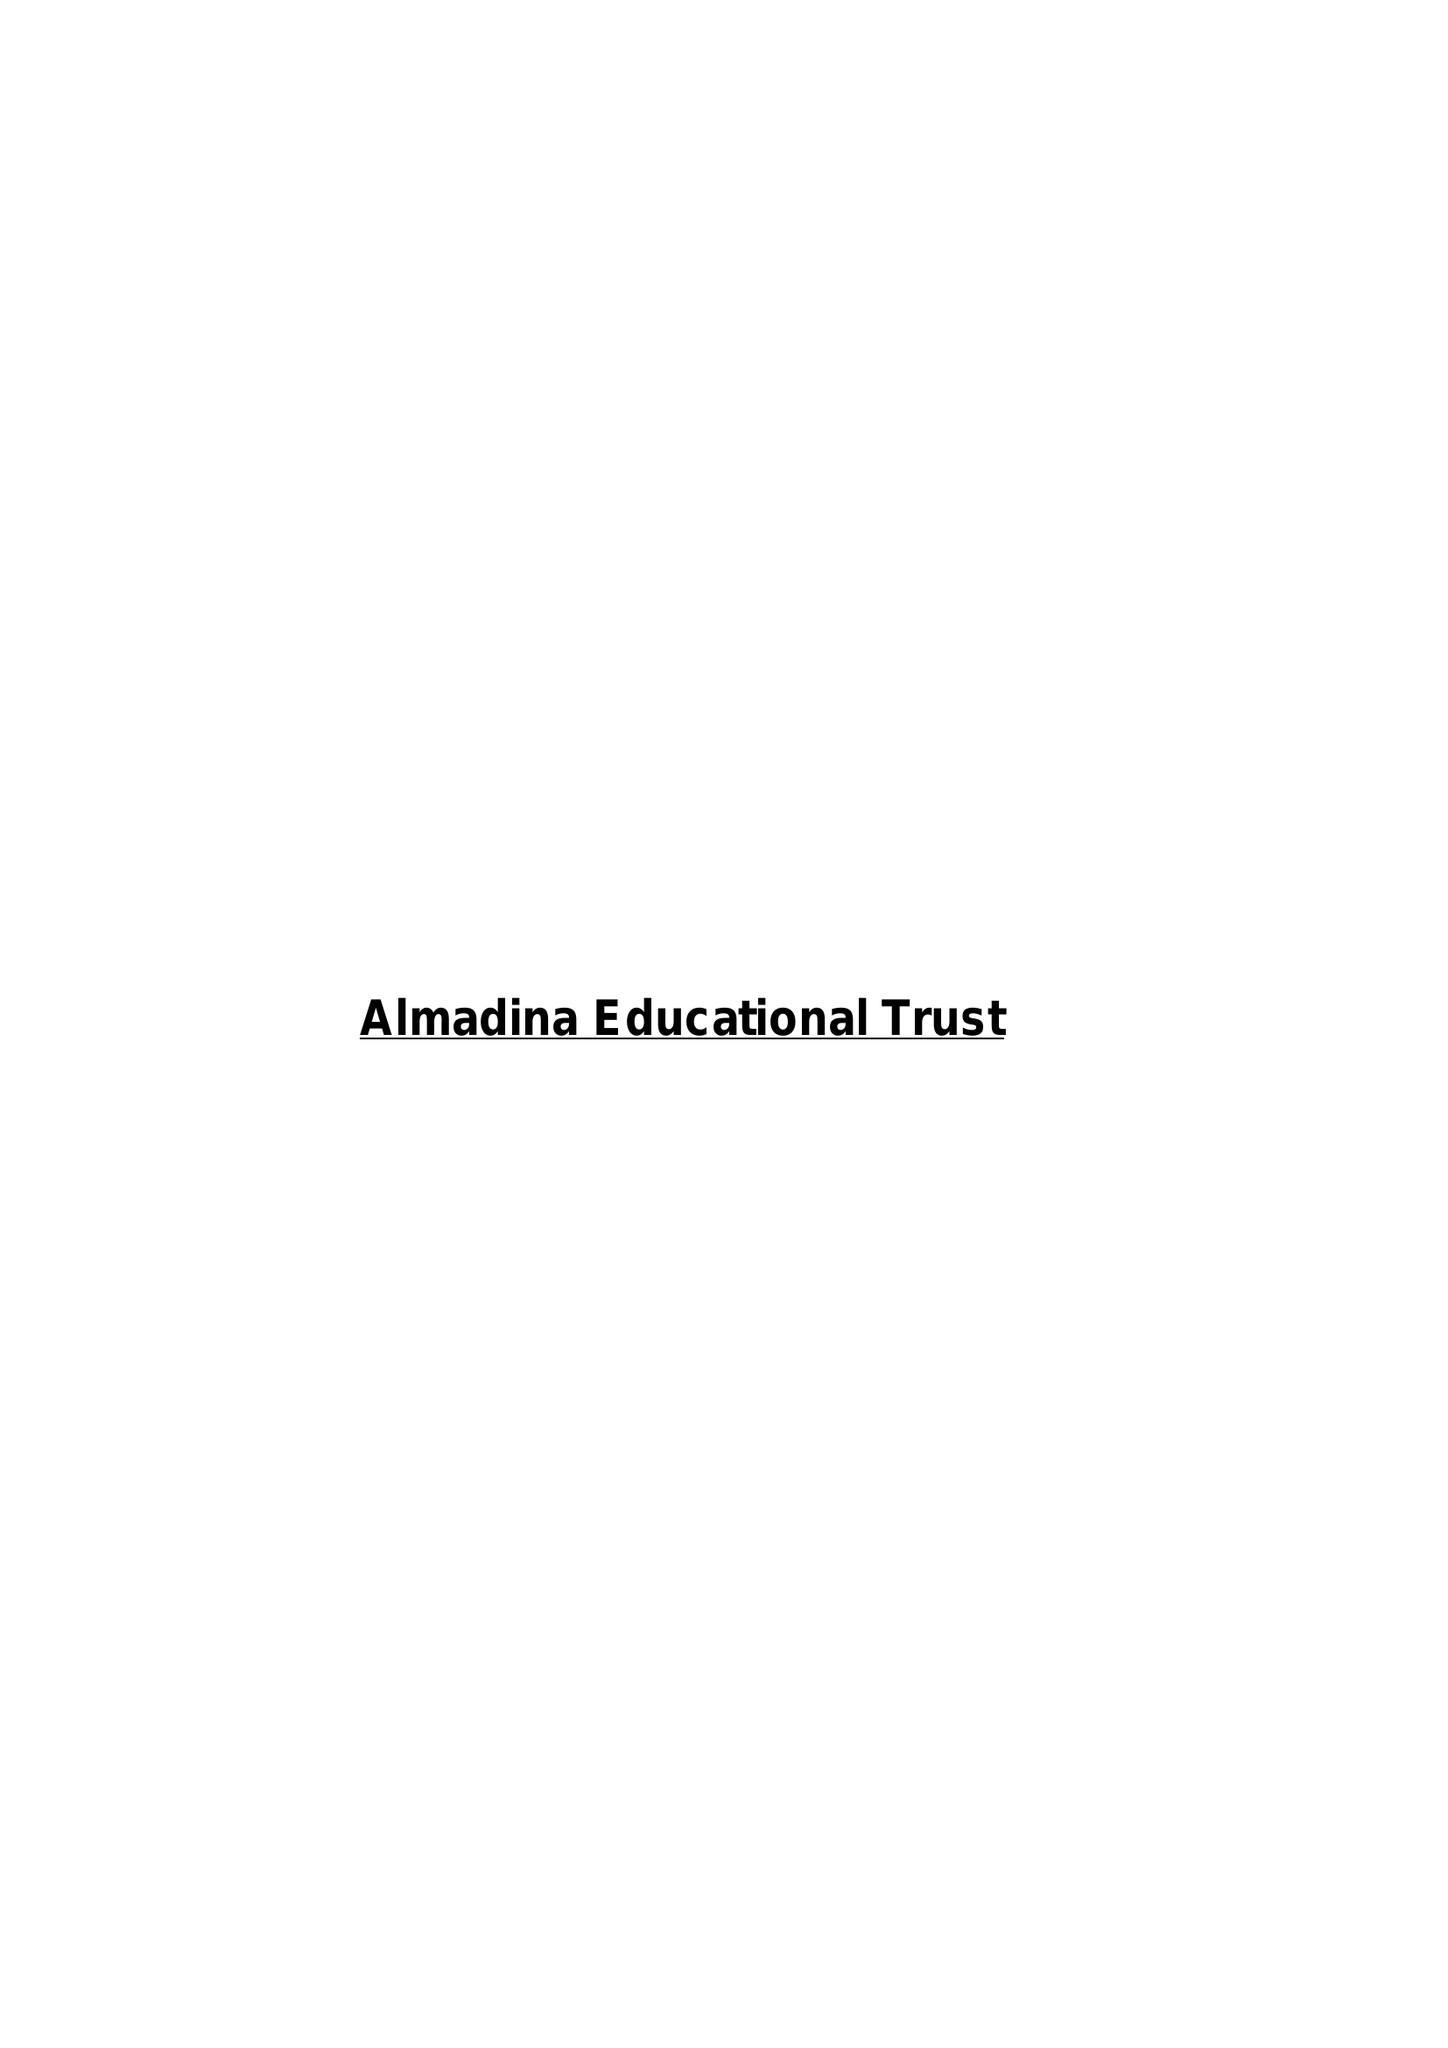What is the value for the income_annually_in_british_pounds?
Answer the question using a single word or phrase. 40330.00 